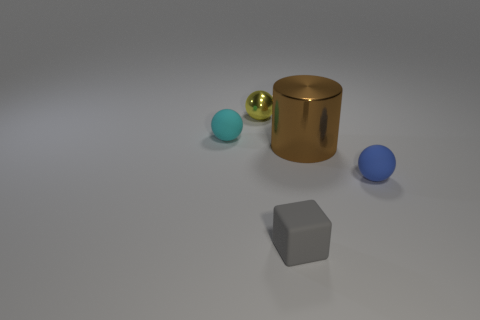Can you tell me the relative sizes of the objects? Certainly! The large golden cylinder is the biggest object in terms of both height and volume. The blue sphere is the smallest in terms of volume. The tiny yellow sphere is small in size but larger than the blue sphere. Finally, the grey geometric object appears to have a moderate size, smaller than the cylinder but larger than the spheres.  What about their positions in relation to each other? The golden cylinder is placed towards the center-right portion of the image, with the two small metal spheres to its left. The tiny yellow sphere is also to the left of the cylinder but closer to the foreground. The blue sphere is positioned to the far left, and the grey cubic object is set apart in the bottom left corner of the image, separate from the group of other objects. 